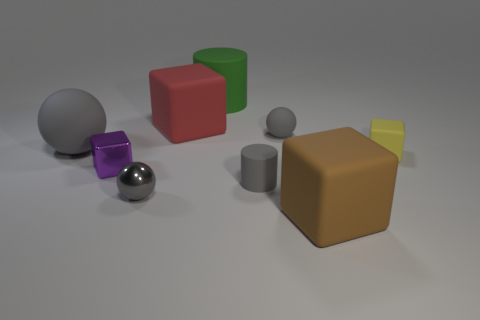Add 1 tiny matte things. How many objects exist? 10 Subtract all spheres. How many objects are left? 6 Add 9 gray rubber cylinders. How many gray rubber cylinders exist? 10 Subtract 0 red spheres. How many objects are left? 9 Subtract all blue metallic objects. Subtract all small cylinders. How many objects are left? 8 Add 7 big red rubber blocks. How many big red rubber blocks are left? 8 